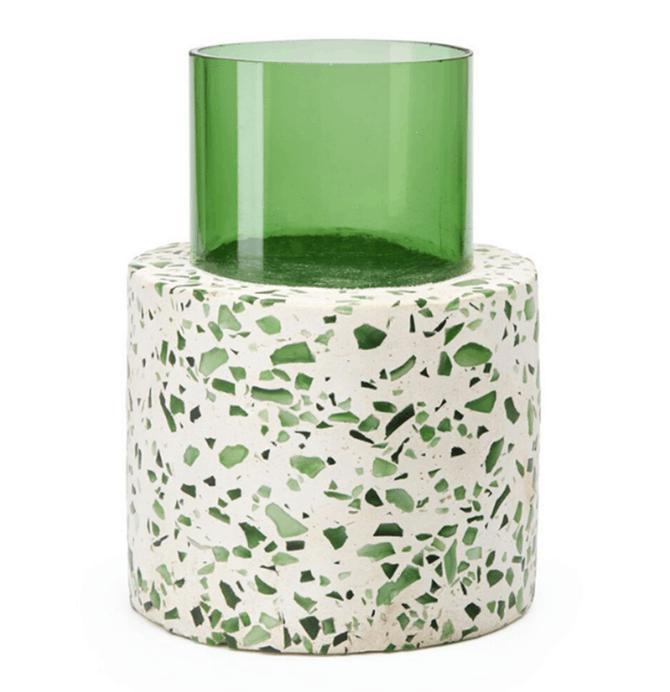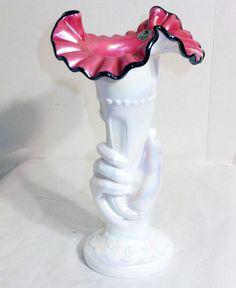The first image is the image on the left, the second image is the image on the right. For the images shown, is this caption "In at least one image there is a single white vase that expanse at the top." true? Answer yes or no. Yes. The first image is the image on the left, the second image is the image on the right. Evaluate the accuracy of this statement regarding the images: "There is a vase with a wide bottom that tapers to be smaller at the opening holding a single plant in it". Is it true? Answer yes or no. No. 